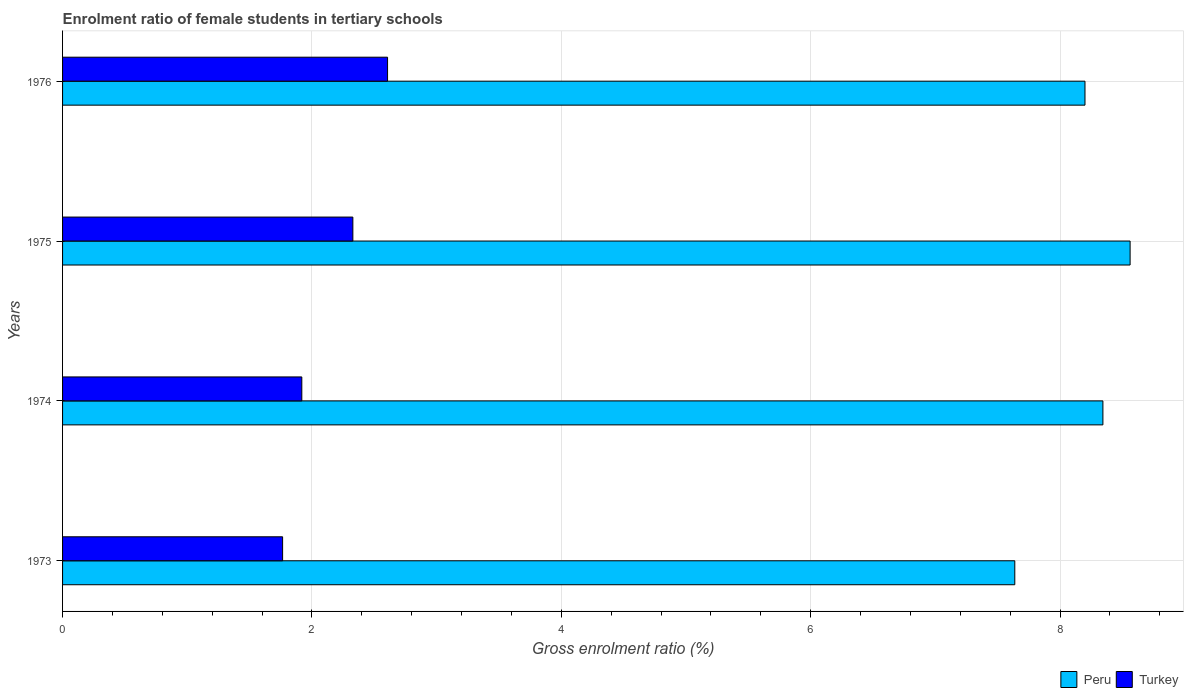How many groups of bars are there?
Ensure brevity in your answer.  4. Are the number of bars on each tick of the Y-axis equal?
Make the answer very short. Yes. How many bars are there on the 1st tick from the top?
Ensure brevity in your answer.  2. How many bars are there on the 1st tick from the bottom?
Offer a very short reply. 2. What is the label of the 3rd group of bars from the top?
Offer a terse response. 1974. What is the enrolment ratio of female students in tertiary schools in Peru in 1976?
Make the answer very short. 8.2. Across all years, what is the maximum enrolment ratio of female students in tertiary schools in Peru?
Your answer should be compact. 8.56. Across all years, what is the minimum enrolment ratio of female students in tertiary schools in Peru?
Your answer should be very brief. 7.64. In which year was the enrolment ratio of female students in tertiary schools in Peru maximum?
Offer a terse response. 1975. In which year was the enrolment ratio of female students in tertiary schools in Turkey minimum?
Offer a very short reply. 1973. What is the total enrolment ratio of female students in tertiary schools in Turkey in the graph?
Your answer should be very brief. 8.62. What is the difference between the enrolment ratio of female students in tertiary schools in Peru in 1974 and that in 1975?
Give a very brief answer. -0.22. What is the difference between the enrolment ratio of female students in tertiary schools in Peru in 1975 and the enrolment ratio of female students in tertiary schools in Turkey in 1974?
Provide a short and direct response. 6.64. What is the average enrolment ratio of female students in tertiary schools in Turkey per year?
Provide a succinct answer. 2.15. In the year 1976, what is the difference between the enrolment ratio of female students in tertiary schools in Turkey and enrolment ratio of female students in tertiary schools in Peru?
Offer a terse response. -5.59. What is the ratio of the enrolment ratio of female students in tertiary schools in Peru in 1973 to that in 1974?
Offer a terse response. 0.92. Is the difference between the enrolment ratio of female students in tertiary schools in Turkey in 1974 and 1975 greater than the difference between the enrolment ratio of female students in tertiary schools in Peru in 1974 and 1975?
Your answer should be very brief. No. What is the difference between the highest and the second highest enrolment ratio of female students in tertiary schools in Turkey?
Provide a short and direct response. 0.28. What is the difference between the highest and the lowest enrolment ratio of female students in tertiary schools in Peru?
Your response must be concise. 0.92. In how many years, is the enrolment ratio of female students in tertiary schools in Peru greater than the average enrolment ratio of female students in tertiary schools in Peru taken over all years?
Provide a short and direct response. 3. Is the sum of the enrolment ratio of female students in tertiary schools in Turkey in 1974 and 1976 greater than the maximum enrolment ratio of female students in tertiary schools in Peru across all years?
Your answer should be compact. No. What does the 2nd bar from the top in 1975 represents?
Your answer should be very brief. Peru. What is the difference between two consecutive major ticks on the X-axis?
Your answer should be compact. 2. Does the graph contain any zero values?
Give a very brief answer. No. How are the legend labels stacked?
Offer a terse response. Horizontal. What is the title of the graph?
Ensure brevity in your answer.  Enrolment ratio of female students in tertiary schools. Does "El Salvador" appear as one of the legend labels in the graph?
Ensure brevity in your answer.  No. What is the Gross enrolment ratio (%) in Peru in 1973?
Provide a short and direct response. 7.64. What is the Gross enrolment ratio (%) in Turkey in 1973?
Ensure brevity in your answer.  1.76. What is the Gross enrolment ratio (%) in Peru in 1974?
Make the answer very short. 8.34. What is the Gross enrolment ratio (%) of Turkey in 1974?
Make the answer very short. 1.92. What is the Gross enrolment ratio (%) of Peru in 1975?
Make the answer very short. 8.56. What is the Gross enrolment ratio (%) in Turkey in 1975?
Keep it short and to the point. 2.33. What is the Gross enrolment ratio (%) in Peru in 1976?
Give a very brief answer. 8.2. What is the Gross enrolment ratio (%) in Turkey in 1976?
Your answer should be very brief. 2.61. Across all years, what is the maximum Gross enrolment ratio (%) of Peru?
Offer a very short reply. 8.56. Across all years, what is the maximum Gross enrolment ratio (%) in Turkey?
Your answer should be very brief. 2.61. Across all years, what is the minimum Gross enrolment ratio (%) of Peru?
Offer a terse response. 7.64. Across all years, what is the minimum Gross enrolment ratio (%) in Turkey?
Your answer should be very brief. 1.76. What is the total Gross enrolment ratio (%) in Peru in the graph?
Keep it short and to the point. 32.74. What is the total Gross enrolment ratio (%) of Turkey in the graph?
Make the answer very short. 8.62. What is the difference between the Gross enrolment ratio (%) in Peru in 1973 and that in 1974?
Provide a succinct answer. -0.71. What is the difference between the Gross enrolment ratio (%) of Turkey in 1973 and that in 1974?
Give a very brief answer. -0.15. What is the difference between the Gross enrolment ratio (%) in Peru in 1973 and that in 1975?
Provide a succinct answer. -0.92. What is the difference between the Gross enrolment ratio (%) in Turkey in 1973 and that in 1975?
Offer a very short reply. -0.56. What is the difference between the Gross enrolment ratio (%) in Peru in 1973 and that in 1976?
Give a very brief answer. -0.56. What is the difference between the Gross enrolment ratio (%) of Turkey in 1973 and that in 1976?
Give a very brief answer. -0.84. What is the difference between the Gross enrolment ratio (%) in Peru in 1974 and that in 1975?
Your answer should be very brief. -0.22. What is the difference between the Gross enrolment ratio (%) of Turkey in 1974 and that in 1975?
Offer a terse response. -0.41. What is the difference between the Gross enrolment ratio (%) in Peru in 1974 and that in 1976?
Give a very brief answer. 0.14. What is the difference between the Gross enrolment ratio (%) in Turkey in 1974 and that in 1976?
Provide a succinct answer. -0.69. What is the difference between the Gross enrolment ratio (%) in Peru in 1975 and that in 1976?
Keep it short and to the point. 0.36. What is the difference between the Gross enrolment ratio (%) of Turkey in 1975 and that in 1976?
Your answer should be compact. -0.28. What is the difference between the Gross enrolment ratio (%) in Peru in 1973 and the Gross enrolment ratio (%) in Turkey in 1974?
Give a very brief answer. 5.72. What is the difference between the Gross enrolment ratio (%) in Peru in 1973 and the Gross enrolment ratio (%) in Turkey in 1975?
Offer a very short reply. 5.31. What is the difference between the Gross enrolment ratio (%) in Peru in 1973 and the Gross enrolment ratio (%) in Turkey in 1976?
Ensure brevity in your answer.  5.03. What is the difference between the Gross enrolment ratio (%) in Peru in 1974 and the Gross enrolment ratio (%) in Turkey in 1975?
Ensure brevity in your answer.  6.02. What is the difference between the Gross enrolment ratio (%) in Peru in 1974 and the Gross enrolment ratio (%) in Turkey in 1976?
Provide a short and direct response. 5.74. What is the difference between the Gross enrolment ratio (%) in Peru in 1975 and the Gross enrolment ratio (%) in Turkey in 1976?
Give a very brief answer. 5.96. What is the average Gross enrolment ratio (%) of Peru per year?
Offer a very short reply. 8.19. What is the average Gross enrolment ratio (%) of Turkey per year?
Your answer should be compact. 2.15. In the year 1973, what is the difference between the Gross enrolment ratio (%) of Peru and Gross enrolment ratio (%) of Turkey?
Your answer should be very brief. 5.87. In the year 1974, what is the difference between the Gross enrolment ratio (%) of Peru and Gross enrolment ratio (%) of Turkey?
Your response must be concise. 6.42. In the year 1975, what is the difference between the Gross enrolment ratio (%) of Peru and Gross enrolment ratio (%) of Turkey?
Offer a terse response. 6.23. In the year 1976, what is the difference between the Gross enrolment ratio (%) in Peru and Gross enrolment ratio (%) in Turkey?
Keep it short and to the point. 5.59. What is the ratio of the Gross enrolment ratio (%) in Peru in 1973 to that in 1974?
Offer a very short reply. 0.92. What is the ratio of the Gross enrolment ratio (%) of Turkey in 1973 to that in 1974?
Your answer should be very brief. 0.92. What is the ratio of the Gross enrolment ratio (%) of Peru in 1973 to that in 1975?
Offer a very short reply. 0.89. What is the ratio of the Gross enrolment ratio (%) of Turkey in 1973 to that in 1975?
Offer a very short reply. 0.76. What is the ratio of the Gross enrolment ratio (%) in Peru in 1973 to that in 1976?
Provide a short and direct response. 0.93. What is the ratio of the Gross enrolment ratio (%) in Turkey in 1973 to that in 1976?
Offer a very short reply. 0.68. What is the ratio of the Gross enrolment ratio (%) of Peru in 1974 to that in 1975?
Ensure brevity in your answer.  0.97. What is the ratio of the Gross enrolment ratio (%) in Turkey in 1974 to that in 1975?
Offer a very short reply. 0.82. What is the ratio of the Gross enrolment ratio (%) in Peru in 1974 to that in 1976?
Provide a succinct answer. 1.02. What is the ratio of the Gross enrolment ratio (%) of Turkey in 1974 to that in 1976?
Keep it short and to the point. 0.74. What is the ratio of the Gross enrolment ratio (%) of Peru in 1975 to that in 1976?
Give a very brief answer. 1.04. What is the ratio of the Gross enrolment ratio (%) of Turkey in 1975 to that in 1976?
Your response must be concise. 0.89. What is the difference between the highest and the second highest Gross enrolment ratio (%) in Peru?
Make the answer very short. 0.22. What is the difference between the highest and the second highest Gross enrolment ratio (%) in Turkey?
Offer a very short reply. 0.28. What is the difference between the highest and the lowest Gross enrolment ratio (%) in Peru?
Keep it short and to the point. 0.92. What is the difference between the highest and the lowest Gross enrolment ratio (%) of Turkey?
Provide a short and direct response. 0.84. 